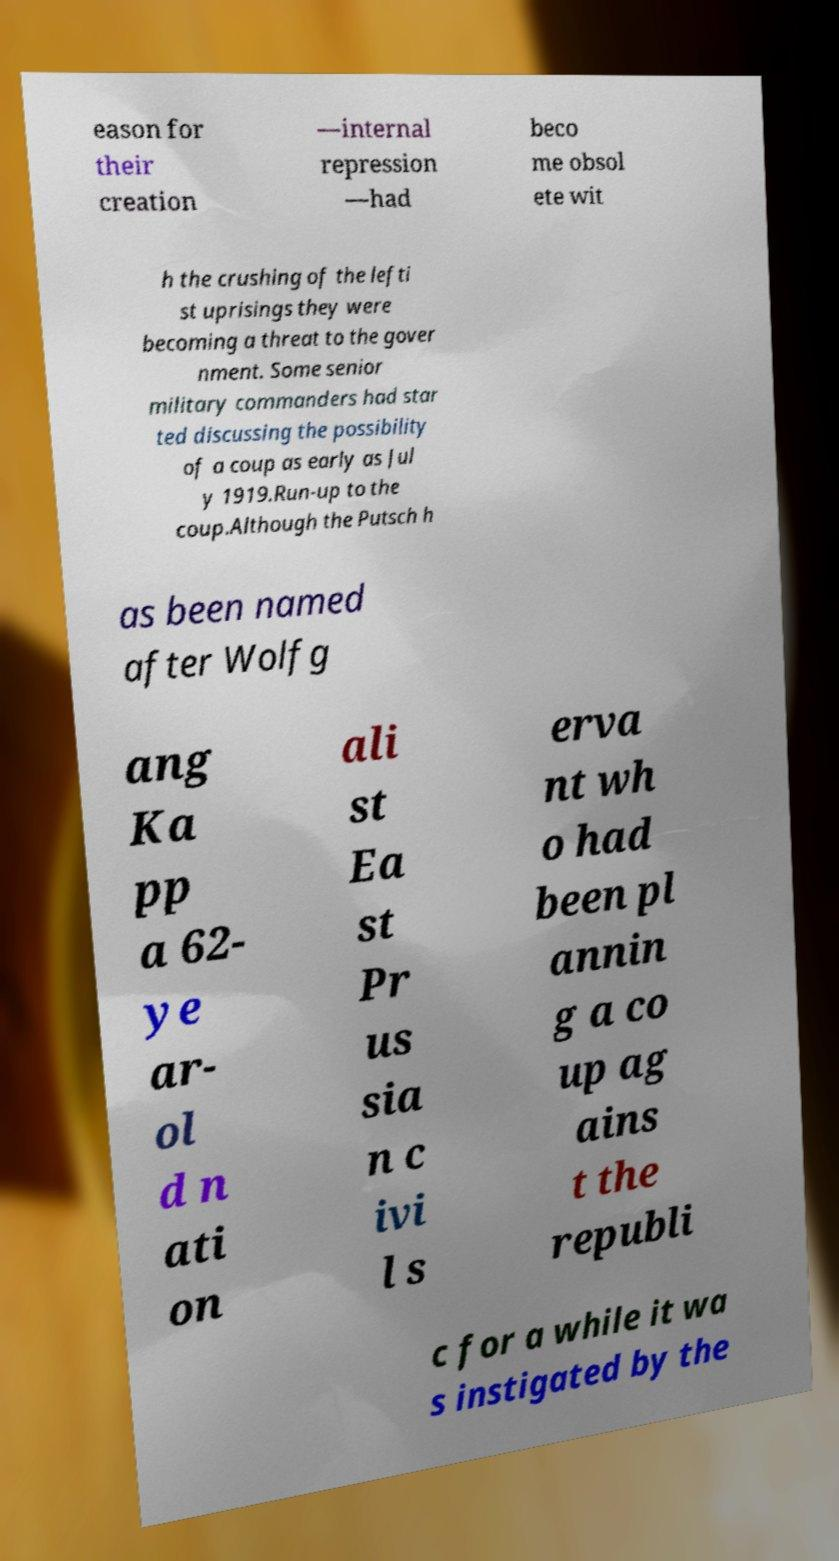Could you assist in decoding the text presented in this image and type it out clearly? eason for their creation —internal repression —had beco me obsol ete wit h the crushing of the lefti st uprisings they were becoming a threat to the gover nment. Some senior military commanders had star ted discussing the possibility of a coup as early as Jul y 1919.Run-up to the coup.Although the Putsch h as been named after Wolfg ang Ka pp a 62- ye ar- ol d n ati on ali st Ea st Pr us sia n c ivi l s erva nt wh o had been pl annin g a co up ag ains t the republi c for a while it wa s instigated by the 